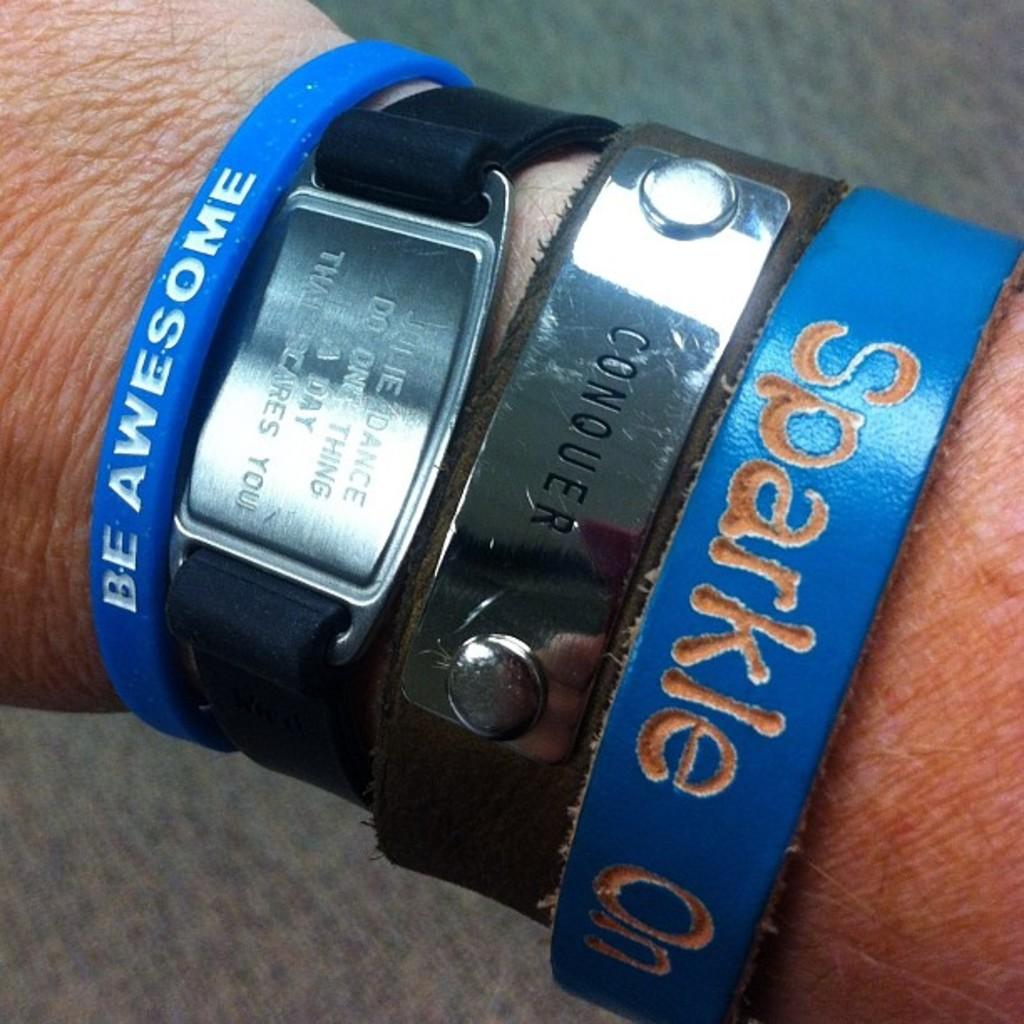<image>
Provide a brief description of the given image. A person wears several bracelets with words on them, including "be awesome" and "conquer." 